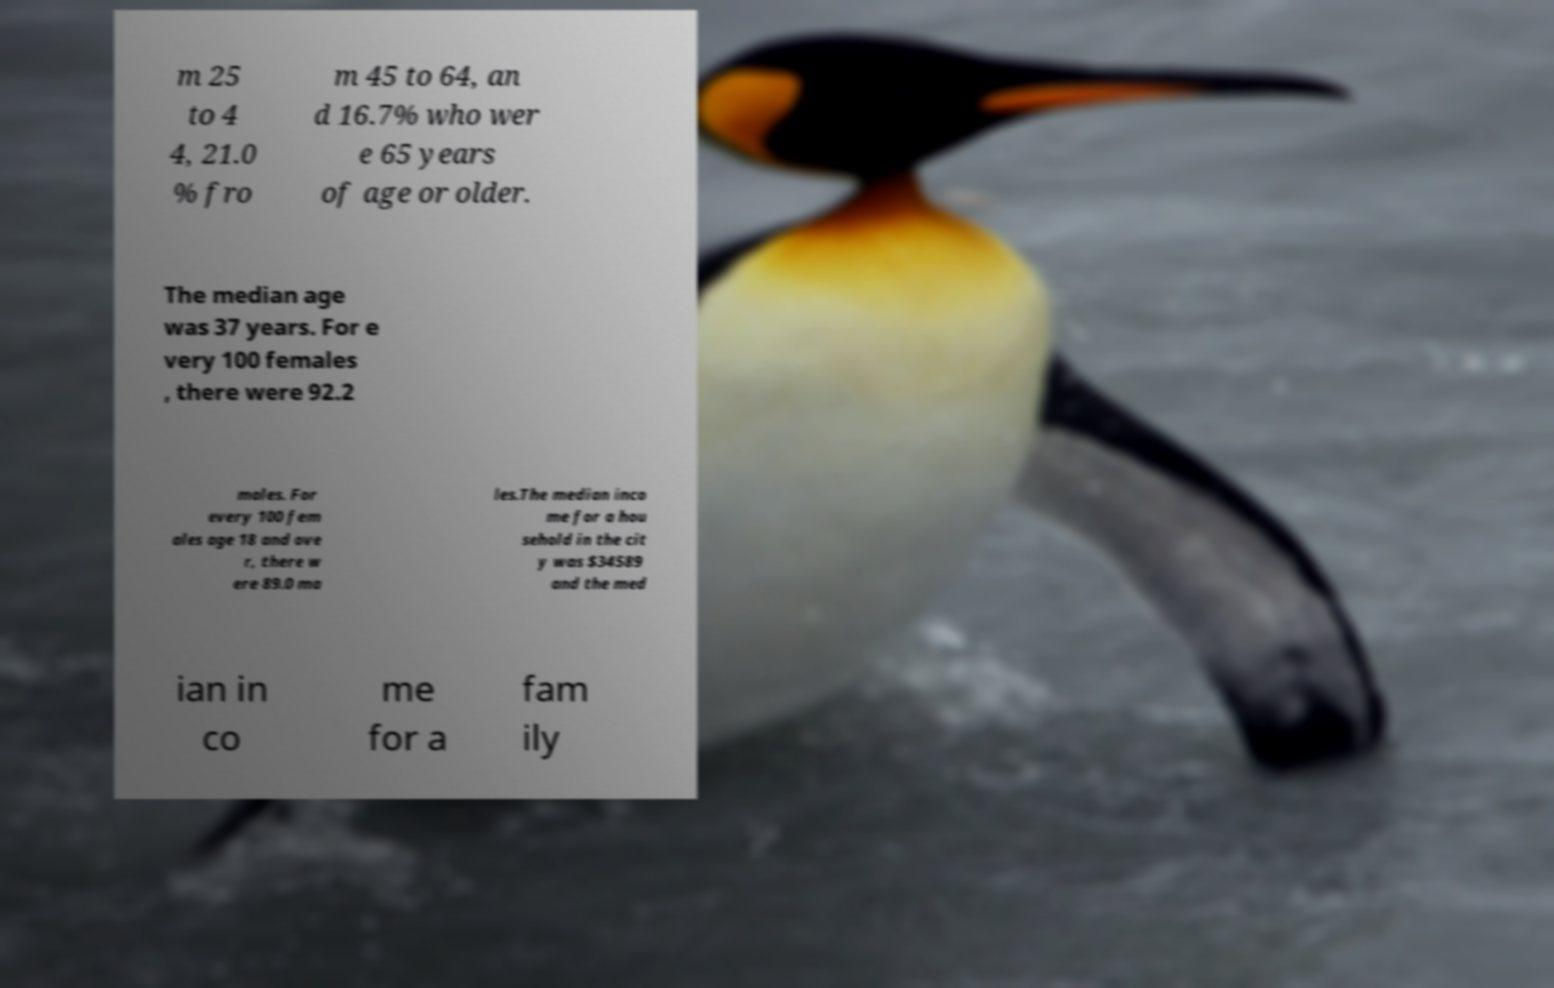What messages or text are displayed in this image? I need them in a readable, typed format. m 25 to 4 4, 21.0 % fro m 45 to 64, an d 16.7% who wer e 65 years of age or older. The median age was 37 years. For e very 100 females , there were 92.2 males. For every 100 fem ales age 18 and ove r, there w ere 89.0 ma les.The median inco me for a hou sehold in the cit y was $34589 and the med ian in co me for a fam ily 